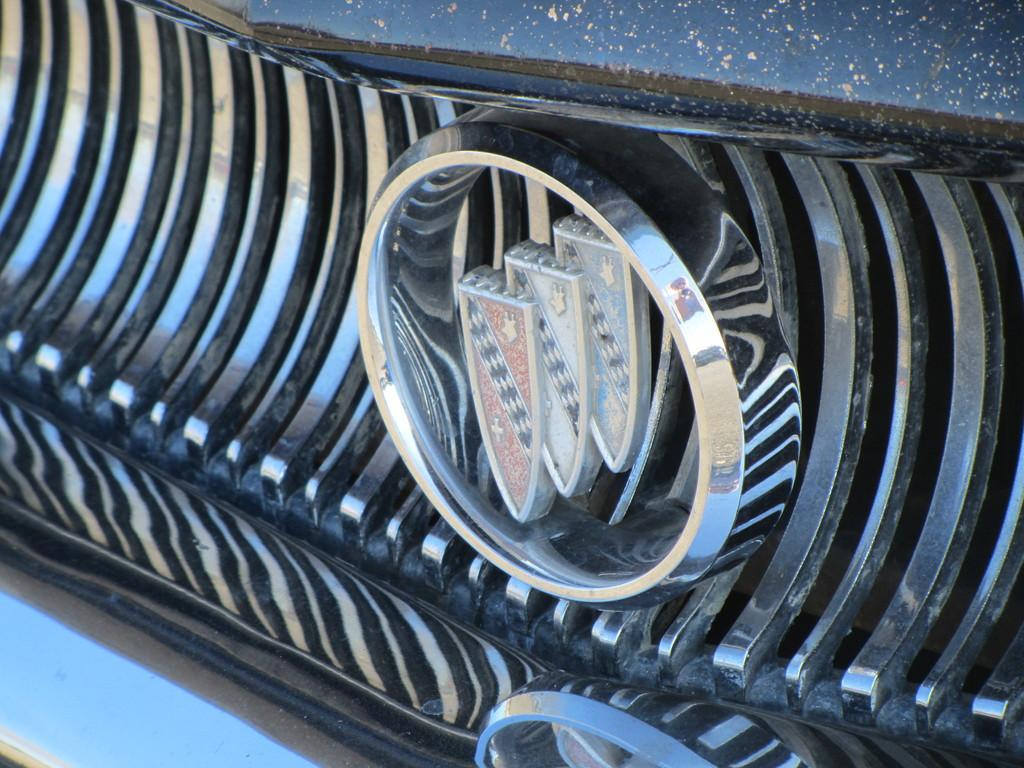What is the main feature of the image? There is a logo in the image. What type of soda is being advertised by the logo in the image? There is no soda or advertisement present in the image; it only features a logo. What type of authority is depicted in the logo in the image? There is no authority depicted in the logo in the image; it only features a logo. 